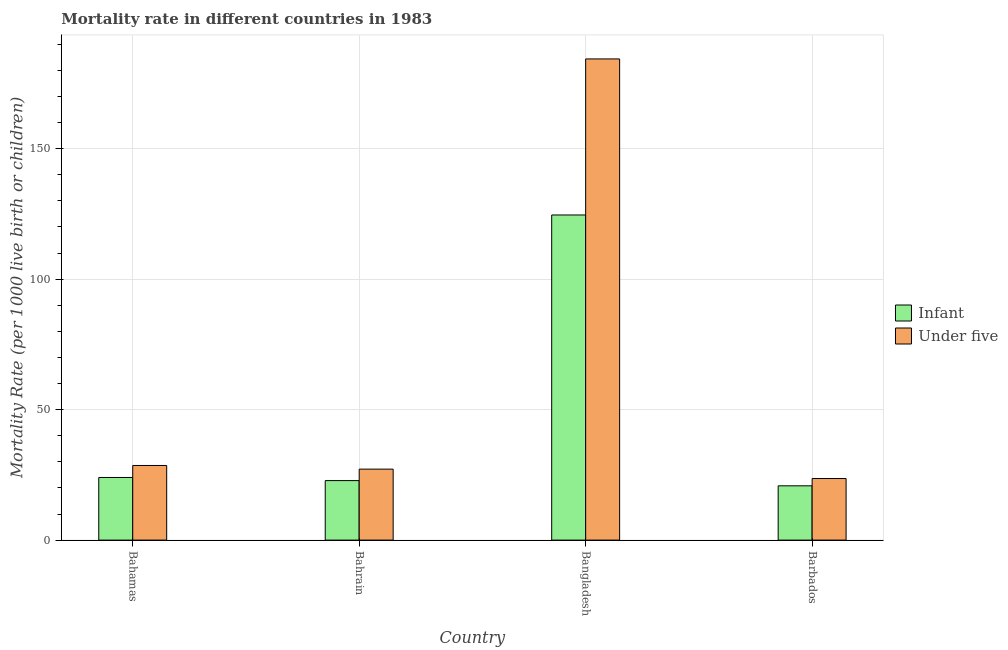How many different coloured bars are there?
Your response must be concise. 2. How many groups of bars are there?
Offer a very short reply. 4. Are the number of bars per tick equal to the number of legend labels?
Ensure brevity in your answer.  Yes. Are the number of bars on each tick of the X-axis equal?
Your answer should be compact. Yes. How many bars are there on the 4th tick from the left?
Your response must be concise. 2. What is the label of the 2nd group of bars from the left?
Offer a very short reply. Bahrain. What is the infant mortality rate in Bahrain?
Your response must be concise. 22.8. Across all countries, what is the maximum infant mortality rate?
Your answer should be very brief. 124.6. Across all countries, what is the minimum under-5 mortality rate?
Ensure brevity in your answer.  23.6. In which country was the infant mortality rate minimum?
Your response must be concise. Barbados. What is the total infant mortality rate in the graph?
Ensure brevity in your answer.  192.2. What is the difference between the infant mortality rate in Bahamas and that in Bahrain?
Offer a very short reply. 1.2. What is the difference between the under-5 mortality rate in Bahamas and the infant mortality rate in Barbados?
Offer a terse response. 7.8. What is the average under-5 mortality rate per country?
Provide a short and direct response. 65.95. What is the difference between the infant mortality rate and under-5 mortality rate in Bahamas?
Offer a terse response. -4.6. What is the ratio of the under-5 mortality rate in Bahamas to that in Bangladesh?
Ensure brevity in your answer.  0.16. Is the difference between the infant mortality rate in Bahrain and Barbados greater than the difference between the under-5 mortality rate in Bahrain and Barbados?
Your answer should be compact. No. What is the difference between the highest and the second highest under-5 mortality rate?
Make the answer very short. 155.8. What is the difference between the highest and the lowest infant mortality rate?
Provide a succinct answer. 103.8. In how many countries, is the infant mortality rate greater than the average infant mortality rate taken over all countries?
Provide a short and direct response. 1. What does the 2nd bar from the left in Bangladesh represents?
Make the answer very short. Under five. What does the 1st bar from the right in Bahrain represents?
Keep it short and to the point. Under five. How many bars are there?
Your answer should be very brief. 8. Are all the bars in the graph horizontal?
Make the answer very short. No. What is the difference between two consecutive major ticks on the Y-axis?
Your answer should be very brief. 50. Does the graph contain grids?
Ensure brevity in your answer.  Yes. Where does the legend appear in the graph?
Keep it short and to the point. Center right. How many legend labels are there?
Make the answer very short. 2. How are the legend labels stacked?
Offer a very short reply. Vertical. What is the title of the graph?
Provide a short and direct response. Mortality rate in different countries in 1983. Does "Quasi money growth" appear as one of the legend labels in the graph?
Your answer should be very brief. No. What is the label or title of the Y-axis?
Make the answer very short. Mortality Rate (per 1000 live birth or children). What is the Mortality Rate (per 1000 live birth or children) in Infant in Bahamas?
Provide a succinct answer. 24. What is the Mortality Rate (per 1000 live birth or children) of Under five in Bahamas?
Provide a short and direct response. 28.6. What is the Mortality Rate (per 1000 live birth or children) of Infant in Bahrain?
Keep it short and to the point. 22.8. What is the Mortality Rate (per 1000 live birth or children) of Under five in Bahrain?
Offer a very short reply. 27.2. What is the Mortality Rate (per 1000 live birth or children) of Infant in Bangladesh?
Offer a terse response. 124.6. What is the Mortality Rate (per 1000 live birth or children) in Under five in Bangladesh?
Your response must be concise. 184.4. What is the Mortality Rate (per 1000 live birth or children) of Infant in Barbados?
Keep it short and to the point. 20.8. What is the Mortality Rate (per 1000 live birth or children) in Under five in Barbados?
Your response must be concise. 23.6. Across all countries, what is the maximum Mortality Rate (per 1000 live birth or children) in Infant?
Your response must be concise. 124.6. Across all countries, what is the maximum Mortality Rate (per 1000 live birth or children) in Under five?
Give a very brief answer. 184.4. Across all countries, what is the minimum Mortality Rate (per 1000 live birth or children) in Infant?
Offer a terse response. 20.8. Across all countries, what is the minimum Mortality Rate (per 1000 live birth or children) of Under five?
Ensure brevity in your answer.  23.6. What is the total Mortality Rate (per 1000 live birth or children) in Infant in the graph?
Offer a terse response. 192.2. What is the total Mortality Rate (per 1000 live birth or children) of Under five in the graph?
Make the answer very short. 263.8. What is the difference between the Mortality Rate (per 1000 live birth or children) in Under five in Bahamas and that in Bahrain?
Provide a short and direct response. 1.4. What is the difference between the Mortality Rate (per 1000 live birth or children) of Infant in Bahamas and that in Bangladesh?
Keep it short and to the point. -100.6. What is the difference between the Mortality Rate (per 1000 live birth or children) in Under five in Bahamas and that in Bangladesh?
Offer a terse response. -155.8. What is the difference between the Mortality Rate (per 1000 live birth or children) of Infant in Bahamas and that in Barbados?
Make the answer very short. 3.2. What is the difference between the Mortality Rate (per 1000 live birth or children) in Under five in Bahamas and that in Barbados?
Make the answer very short. 5. What is the difference between the Mortality Rate (per 1000 live birth or children) of Infant in Bahrain and that in Bangladesh?
Give a very brief answer. -101.8. What is the difference between the Mortality Rate (per 1000 live birth or children) of Under five in Bahrain and that in Bangladesh?
Offer a terse response. -157.2. What is the difference between the Mortality Rate (per 1000 live birth or children) in Infant in Bangladesh and that in Barbados?
Make the answer very short. 103.8. What is the difference between the Mortality Rate (per 1000 live birth or children) of Under five in Bangladesh and that in Barbados?
Provide a short and direct response. 160.8. What is the difference between the Mortality Rate (per 1000 live birth or children) in Infant in Bahamas and the Mortality Rate (per 1000 live birth or children) in Under five in Bangladesh?
Provide a short and direct response. -160.4. What is the difference between the Mortality Rate (per 1000 live birth or children) in Infant in Bahrain and the Mortality Rate (per 1000 live birth or children) in Under five in Bangladesh?
Offer a terse response. -161.6. What is the difference between the Mortality Rate (per 1000 live birth or children) of Infant in Bahrain and the Mortality Rate (per 1000 live birth or children) of Under five in Barbados?
Give a very brief answer. -0.8. What is the difference between the Mortality Rate (per 1000 live birth or children) of Infant in Bangladesh and the Mortality Rate (per 1000 live birth or children) of Under five in Barbados?
Offer a terse response. 101. What is the average Mortality Rate (per 1000 live birth or children) of Infant per country?
Your response must be concise. 48.05. What is the average Mortality Rate (per 1000 live birth or children) in Under five per country?
Keep it short and to the point. 65.95. What is the difference between the Mortality Rate (per 1000 live birth or children) of Infant and Mortality Rate (per 1000 live birth or children) of Under five in Bangladesh?
Your answer should be compact. -59.8. What is the difference between the Mortality Rate (per 1000 live birth or children) in Infant and Mortality Rate (per 1000 live birth or children) in Under five in Barbados?
Offer a very short reply. -2.8. What is the ratio of the Mortality Rate (per 1000 live birth or children) in Infant in Bahamas to that in Bahrain?
Ensure brevity in your answer.  1.05. What is the ratio of the Mortality Rate (per 1000 live birth or children) in Under five in Bahamas to that in Bahrain?
Offer a terse response. 1.05. What is the ratio of the Mortality Rate (per 1000 live birth or children) in Infant in Bahamas to that in Bangladesh?
Your answer should be very brief. 0.19. What is the ratio of the Mortality Rate (per 1000 live birth or children) of Under five in Bahamas to that in Bangladesh?
Provide a succinct answer. 0.16. What is the ratio of the Mortality Rate (per 1000 live birth or children) in Infant in Bahamas to that in Barbados?
Make the answer very short. 1.15. What is the ratio of the Mortality Rate (per 1000 live birth or children) of Under five in Bahamas to that in Barbados?
Provide a short and direct response. 1.21. What is the ratio of the Mortality Rate (per 1000 live birth or children) in Infant in Bahrain to that in Bangladesh?
Your answer should be compact. 0.18. What is the ratio of the Mortality Rate (per 1000 live birth or children) of Under five in Bahrain to that in Bangladesh?
Your answer should be compact. 0.15. What is the ratio of the Mortality Rate (per 1000 live birth or children) in Infant in Bahrain to that in Barbados?
Ensure brevity in your answer.  1.1. What is the ratio of the Mortality Rate (per 1000 live birth or children) of Under five in Bahrain to that in Barbados?
Keep it short and to the point. 1.15. What is the ratio of the Mortality Rate (per 1000 live birth or children) in Infant in Bangladesh to that in Barbados?
Offer a very short reply. 5.99. What is the ratio of the Mortality Rate (per 1000 live birth or children) in Under five in Bangladesh to that in Barbados?
Your answer should be compact. 7.81. What is the difference between the highest and the second highest Mortality Rate (per 1000 live birth or children) in Infant?
Your answer should be very brief. 100.6. What is the difference between the highest and the second highest Mortality Rate (per 1000 live birth or children) of Under five?
Make the answer very short. 155.8. What is the difference between the highest and the lowest Mortality Rate (per 1000 live birth or children) of Infant?
Keep it short and to the point. 103.8. What is the difference between the highest and the lowest Mortality Rate (per 1000 live birth or children) in Under five?
Your response must be concise. 160.8. 